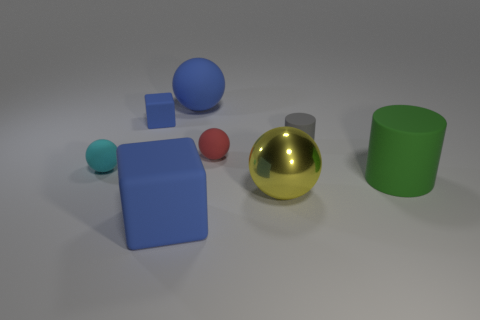Subtract all rubber balls. How many balls are left? 1 Add 1 green metallic objects. How many objects exist? 9 Subtract 1 cylinders. How many cylinders are left? 1 Subtract all cyan spheres. How many spheres are left? 3 Add 7 large yellow metallic balls. How many large yellow metallic balls are left? 8 Add 8 small blue spheres. How many small blue spheres exist? 8 Subtract 1 gray cylinders. How many objects are left? 7 Subtract all cubes. How many objects are left? 6 Subtract all red cylinders. Subtract all purple cubes. How many cylinders are left? 2 Subtract all purple cylinders. How many cyan blocks are left? 0 